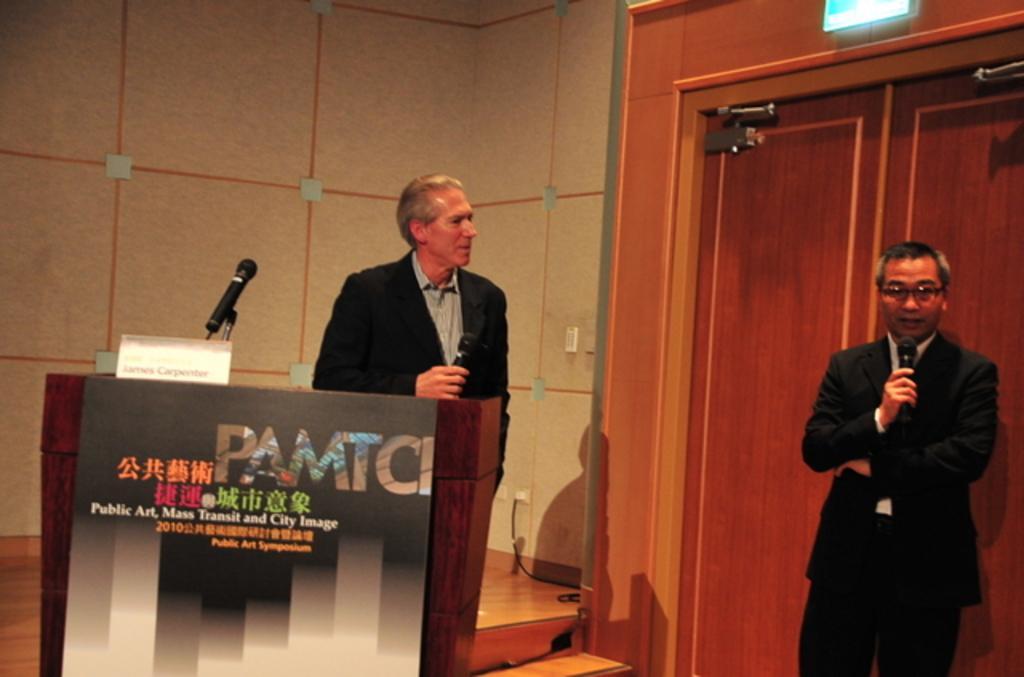Can you describe this image briefly? In this image I can see two persons are standing and holding mics in their hand in front of a table. In the background I can see a wall and door. This image is taken may be in a hall. 